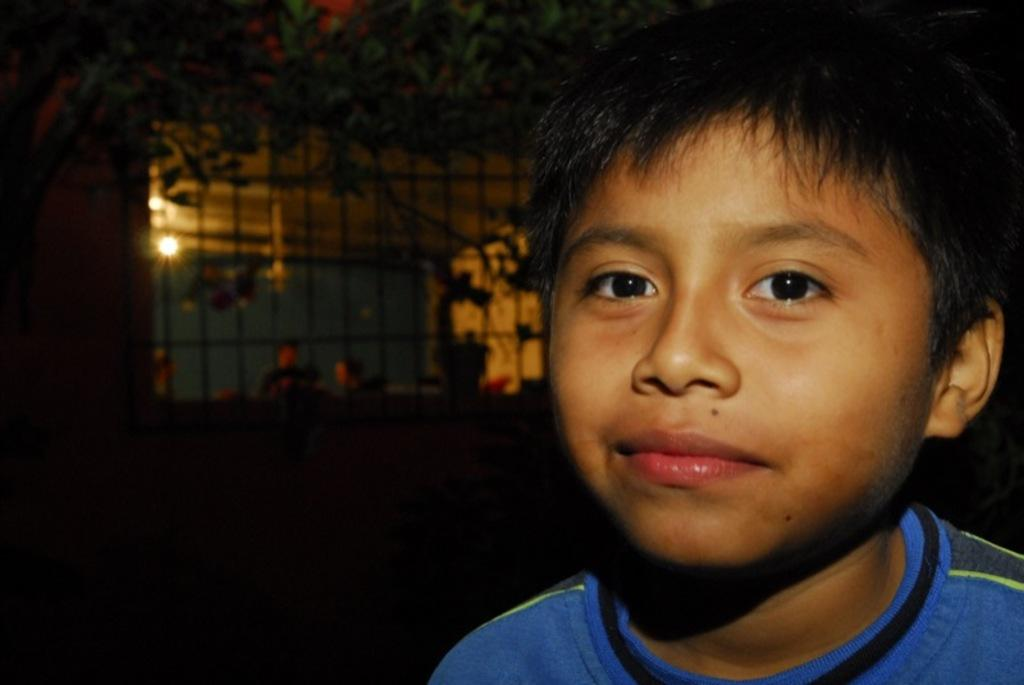What is located on the right side of the image? There is a boy on the right side of the image. What can be seen in the background of the image? There is a window, light, and plants visible in the background of the image. How is the background of the image depicted? The background is blurred. What type of marble is the boy holding in his hand in the image? There is no marble or hand visible in the image; the boy is not holding anything. 